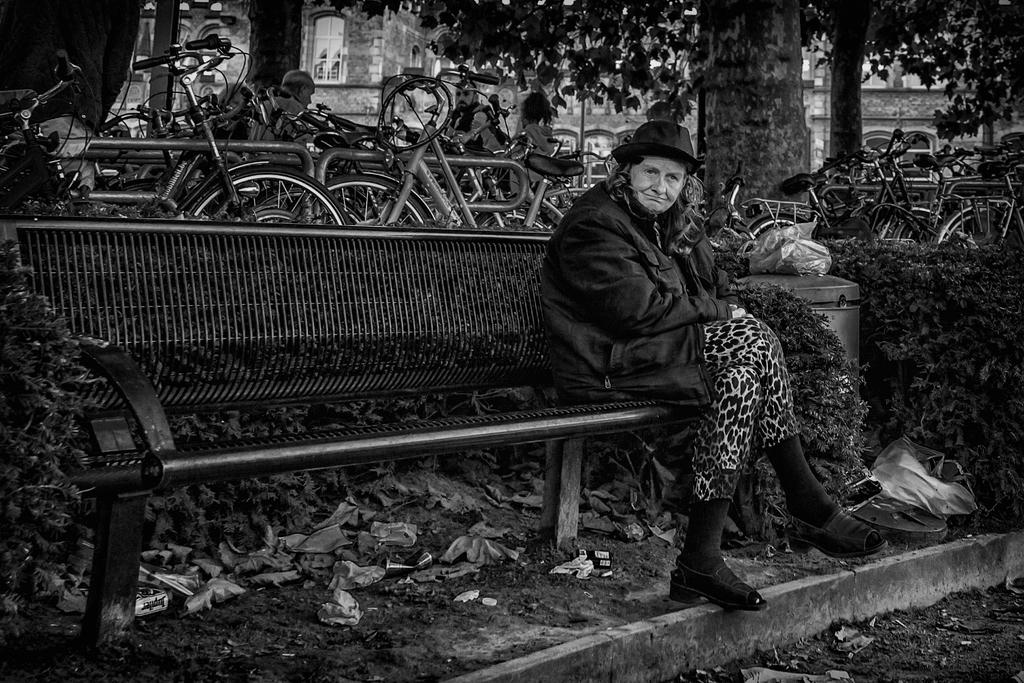What is the woman in the image doing? The woman is sitting on a bench in the image. Where is the bench located? The bench is located in a garden. What can be seen in the background of the image? In the background of the image, there are bicycles, trees, buildings, and a group of people. What type of vegetation is present in the image? Leaves, plants, and grass are visible in the image. What is the texture of the father's shirt in the image? There is no father present in the image, so it is not possible to determine the texture of his shirt. 